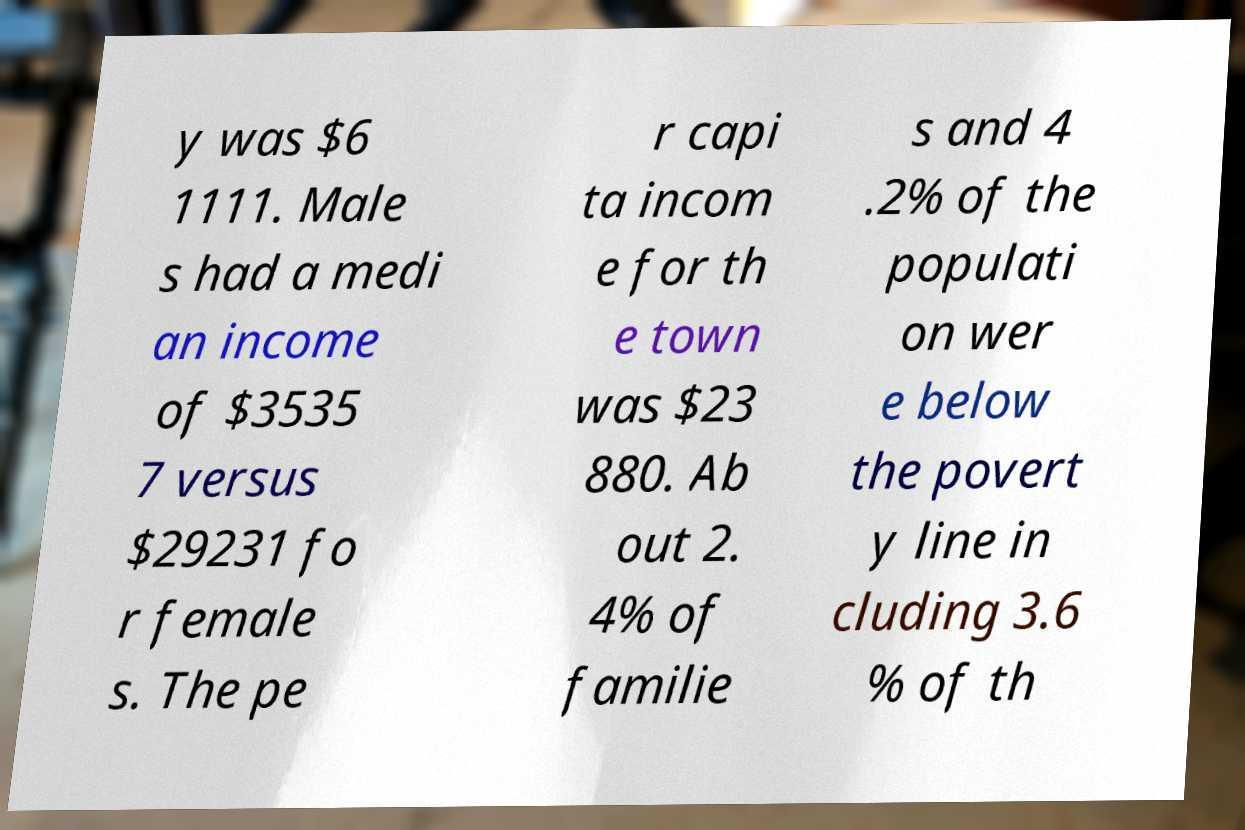Could you assist in decoding the text presented in this image and type it out clearly? y was $6 1111. Male s had a medi an income of $3535 7 versus $29231 fo r female s. The pe r capi ta incom e for th e town was $23 880. Ab out 2. 4% of familie s and 4 .2% of the populati on wer e below the povert y line in cluding 3.6 % of th 